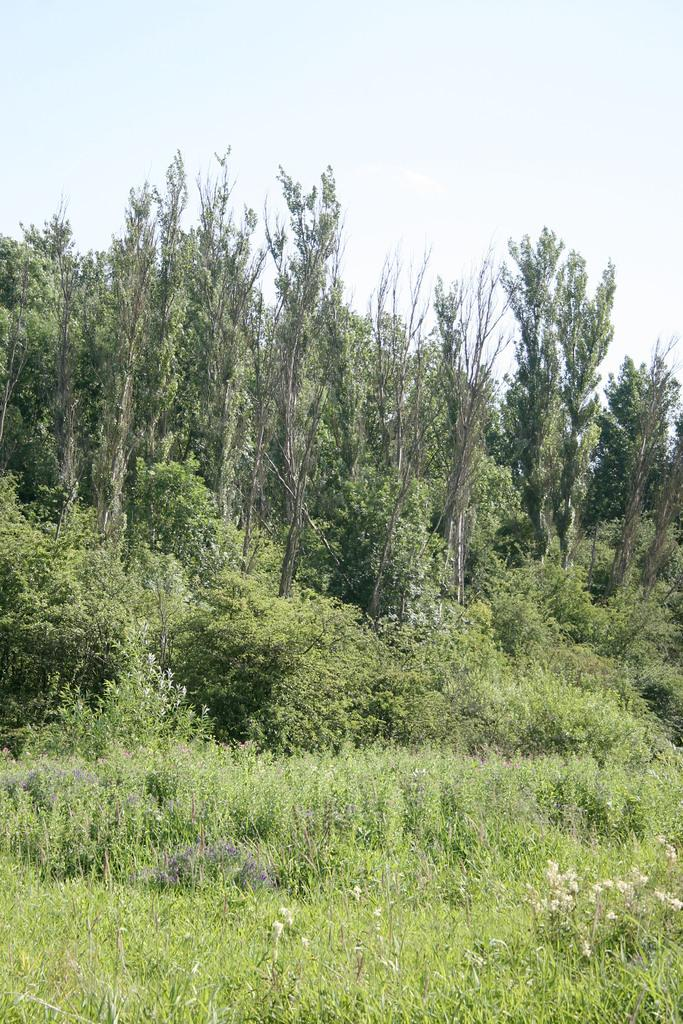What type of vegetation can be seen in the image? There are small plants and grass in the image. What is visible in the background of the image? There are trees in the background of the image. What is visible at the top of the image? The sky is visible at the top of the image. What shape are the boats in the image? There are no boats present in the image. What process is being depicted in the image? The image does not depict a process; it shows small plants, grass, trees, and the sky. 